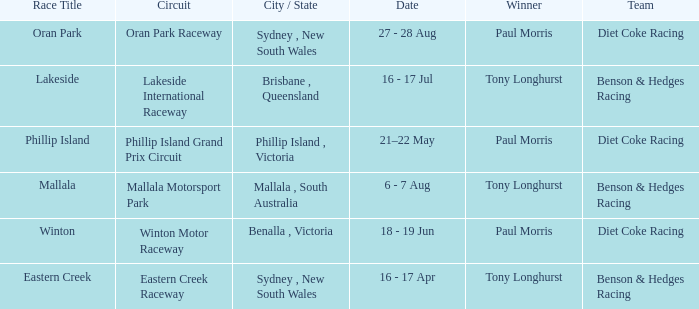What was the name of the driver that won the Lakeside race? Tony Longhurst. 